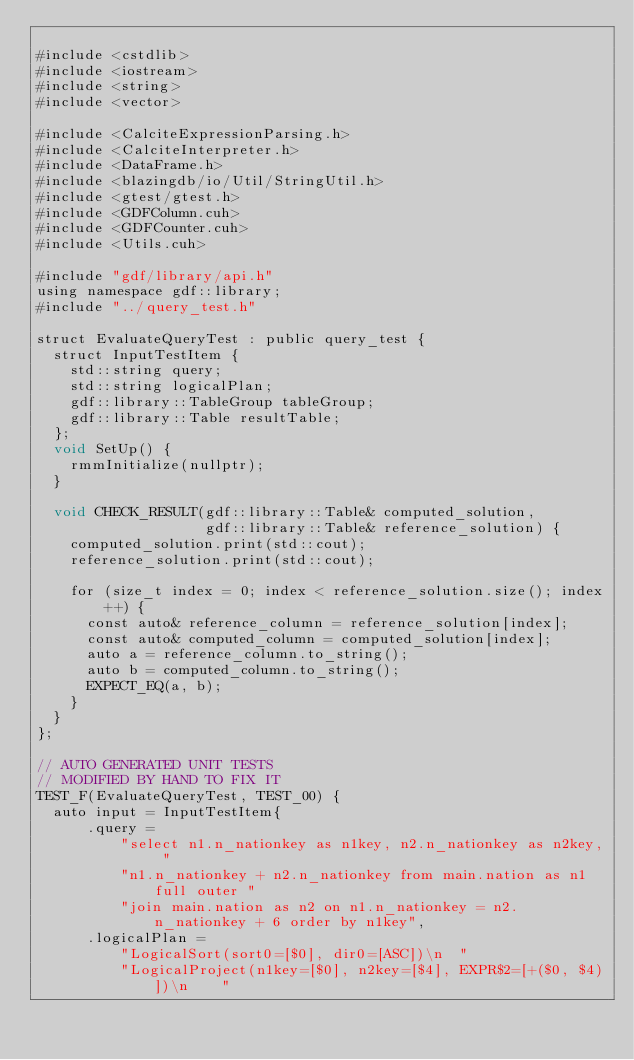Convert code to text. <code><loc_0><loc_0><loc_500><loc_500><_Cuda_>
#include <cstdlib>
#include <iostream>
#include <string>
#include <vector>

#include <CalciteExpressionParsing.h>
#include <CalciteInterpreter.h>
#include <DataFrame.h>
#include <blazingdb/io/Util/StringUtil.h>
#include <gtest/gtest.h>
#include <GDFColumn.cuh>
#include <GDFCounter.cuh>
#include <Utils.cuh>

#include "gdf/library/api.h"
using namespace gdf::library;
#include "../query_test.h"

struct EvaluateQueryTest : public query_test {
  struct InputTestItem {
    std::string query;
    std::string logicalPlan;
    gdf::library::TableGroup tableGroup;
    gdf::library::Table resultTable;
  };
  void SetUp() {
    rmmInitialize(nullptr);
  }
  
  void CHECK_RESULT(gdf::library::Table& computed_solution,
                    gdf::library::Table& reference_solution) {
    computed_solution.print(std::cout);
    reference_solution.print(std::cout);

    for (size_t index = 0; index < reference_solution.size(); index++) {
      const auto& reference_column = reference_solution[index];
      const auto& computed_column = computed_solution[index];
      auto a = reference_column.to_string();
      auto b = computed_column.to_string();
      EXPECT_EQ(a, b);
    }
  }
};

// AUTO GENERATED UNIT TESTS
// MODIFIED BY HAND TO FIX IT 
TEST_F(EvaluateQueryTest, TEST_00) {
  auto input = InputTestItem{
      .query =
          "select n1.n_nationkey as n1key, n2.n_nationkey as n2key, "
          "n1.n_nationkey + n2.n_nationkey from main.nation as n1 full outer "
          "join main.nation as n2 on n1.n_nationkey = n2.n_nationkey + 6 order by n1key",
      .logicalPlan =
          "LogicalSort(sort0=[$0], dir0=[ASC])\n  "
          "LogicalProject(n1key=[$0], n2key=[$4], EXPR$2=[+($0, $4)])\n    "</code> 